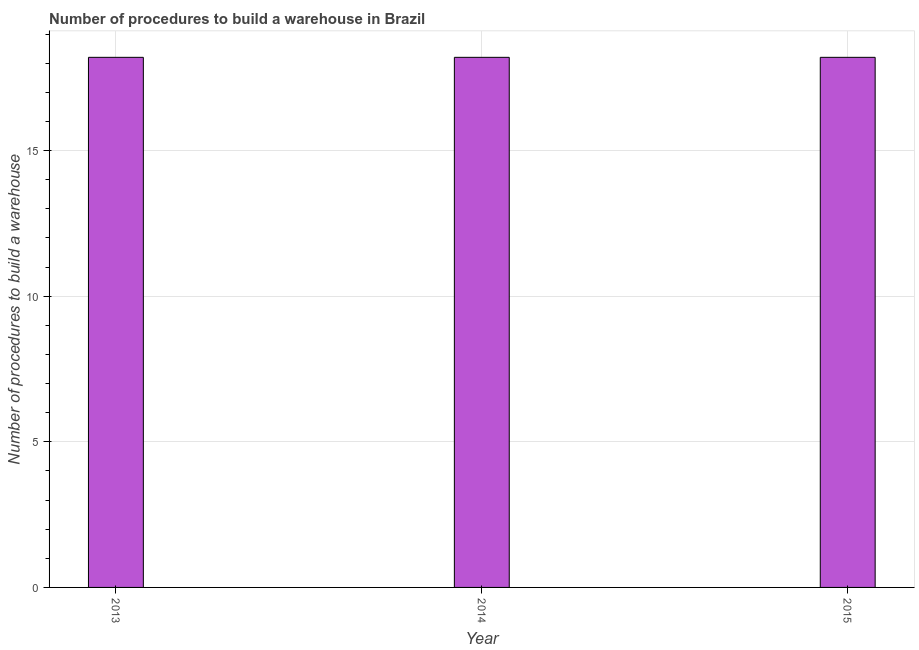Does the graph contain grids?
Provide a short and direct response. Yes. What is the title of the graph?
Offer a very short reply. Number of procedures to build a warehouse in Brazil. What is the label or title of the Y-axis?
Offer a very short reply. Number of procedures to build a warehouse. What is the number of procedures to build a warehouse in 2015?
Your answer should be compact. 18.2. Across all years, what is the maximum number of procedures to build a warehouse?
Give a very brief answer. 18.2. Across all years, what is the minimum number of procedures to build a warehouse?
Keep it short and to the point. 18.2. In which year was the number of procedures to build a warehouse minimum?
Your answer should be very brief. 2013. What is the sum of the number of procedures to build a warehouse?
Your response must be concise. 54.6. What is the average number of procedures to build a warehouse per year?
Keep it short and to the point. 18.2. What is the median number of procedures to build a warehouse?
Provide a succinct answer. 18.2. What is the ratio of the number of procedures to build a warehouse in 2013 to that in 2015?
Give a very brief answer. 1. In how many years, is the number of procedures to build a warehouse greater than the average number of procedures to build a warehouse taken over all years?
Provide a succinct answer. 0. How many bars are there?
Offer a very short reply. 3. Are all the bars in the graph horizontal?
Provide a succinct answer. No. Are the values on the major ticks of Y-axis written in scientific E-notation?
Make the answer very short. No. What is the Number of procedures to build a warehouse of 2013?
Make the answer very short. 18.2. What is the difference between the Number of procedures to build a warehouse in 2014 and 2015?
Your answer should be very brief. 0. What is the ratio of the Number of procedures to build a warehouse in 2014 to that in 2015?
Provide a short and direct response. 1. 